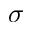Convert formula to latex. <formula><loc_0><loc_0><loc_500><loc_500>\sigma</formula> 